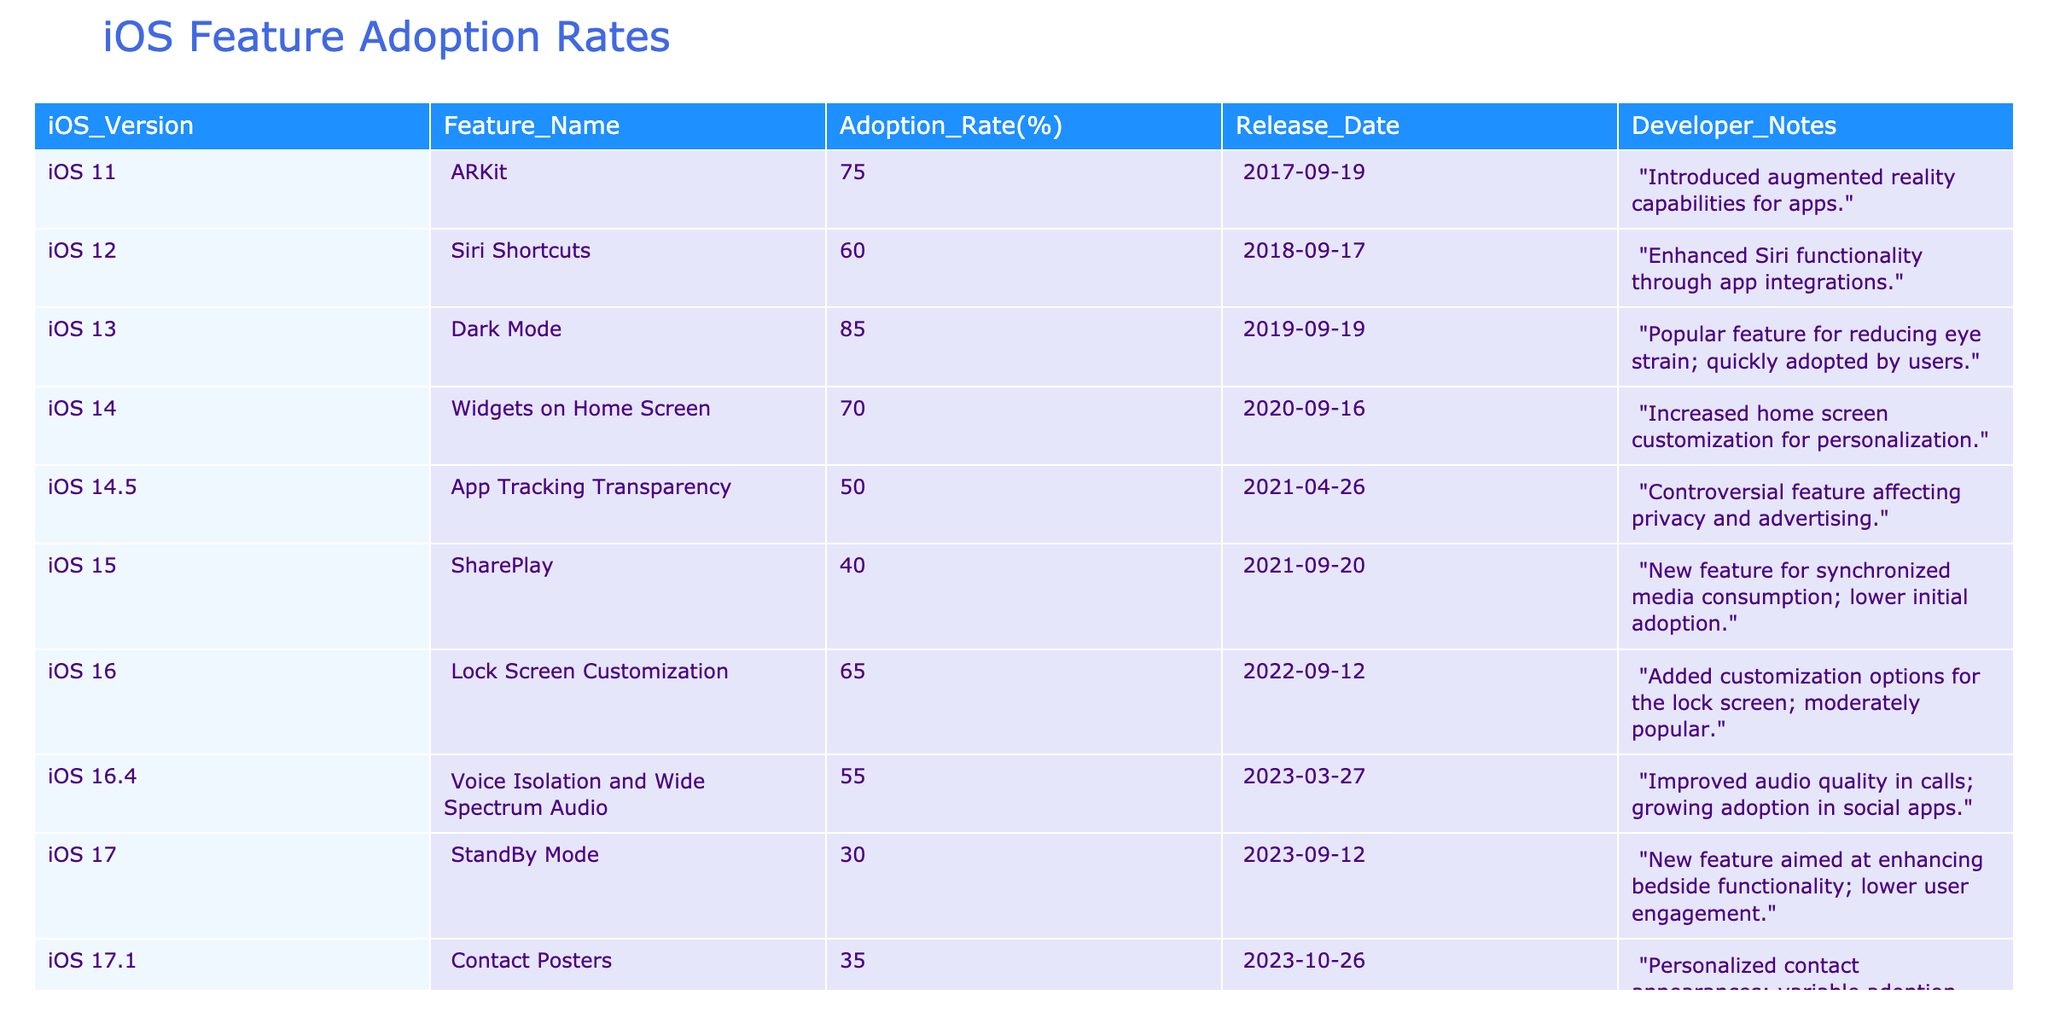What is the adoption rate of Dark Mode in iOS 13? The table shows that the adoption rate of Dark Mode in iOS 13 is 85%.
Answer: 85% Which iOS version introduced ARKit? According to the table, ARKit was introduced in iOS 11.
Answer: iOS 11 What is the difference in adoption rates between Widgets on Home Screen (iOS 14) and SharePlay (iOS 15)? The adoption rate for Widgets on Home Screen is 70%, while for SharePlay it is 40%. The difference is 70 - 40 = 30%.
Answer: 30% Was App Tracking Transparency adopted more widely than SharePlay? The adoption rate for App Tracking Transparency is 50%, which is greater than SharePlay's 40%, thus the statement is true.
Answer: Yes What is the average adoption rate of features introduced from iOS 14 to iOS 17.1? The features and their adoption rates in this range are: Widgets on Home Screen (70%), App Tracking Transparency (50%), SharePlay (40%), Lock Screen Customization (65%), Voice Isolation and Wide Spectrum Audio (55%), StandBy Mode (30%), Contact Posters (35%). The average is (70 + 50 + 40 + 65 + 55 + 30 + 35) / 7 = 47.14%.
Answer: 47.14% Which feature has the lowest adoption rate, and what is the rate? The feature with the lowest adoption rate is StandBy Mode with a rate of 30%.
Answer: StandBy Mode, 30% What was the adoption rate of Siri Shortcuts in iOS 12? The table indicates that the adoption rate of Siri Shortcuts in iOS 12 is 60%.
Answer: 60% Did any features result in adoption rates over 80%? Yes, Dark Mode in iOS 13 had an adoption rate of 85%, which is over 80%.
Answer: Yes How many features had an adoption rate above 60%? The features with an adoption rate above 60% are ARKit (75%), Dark Mode (85%), and Widgets on Home Screen (70%). This totals to three features.
Answer: 3 